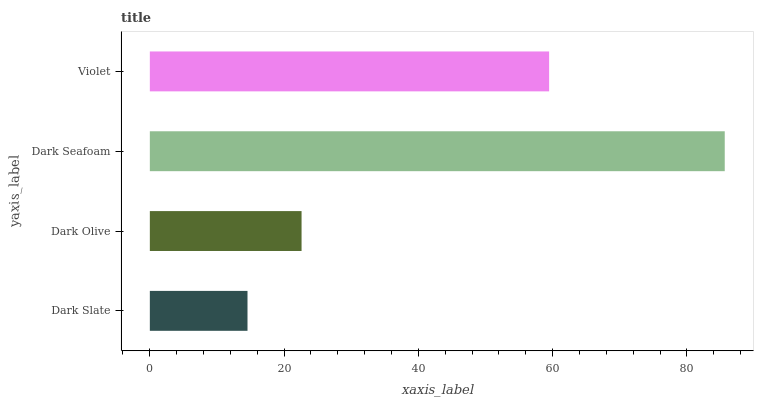Is Dark Slate the minimum?
Answer yes or no. Yes. Is Dark Seafoam the maximum?
Answer yes or no. Yes. Is Dark Olive the minimum?
Answer yes or no. No. Is Dark Olive the maximum?
Answer yes or no. No. Is Dark Olive greater than Dark Slate?
Answer yes or no. Yes. Is Dark Slate less than Dark Olive?
Answer yes or no. Yes. Is Dark Slate greater than Dark Olive?
Answer yes or no. No. Is Dark Olive less than Dark Slate?
Answer yes or no. No. Is Violet the high median?
Answer yes or no. Yes. Is Dark Olive the low median?
Answer yes or no. Yes. Is Dark Slate the high median?
Answer yes or no. No. Is Dark Seafoam the low median?
Answer yes or no. No. 